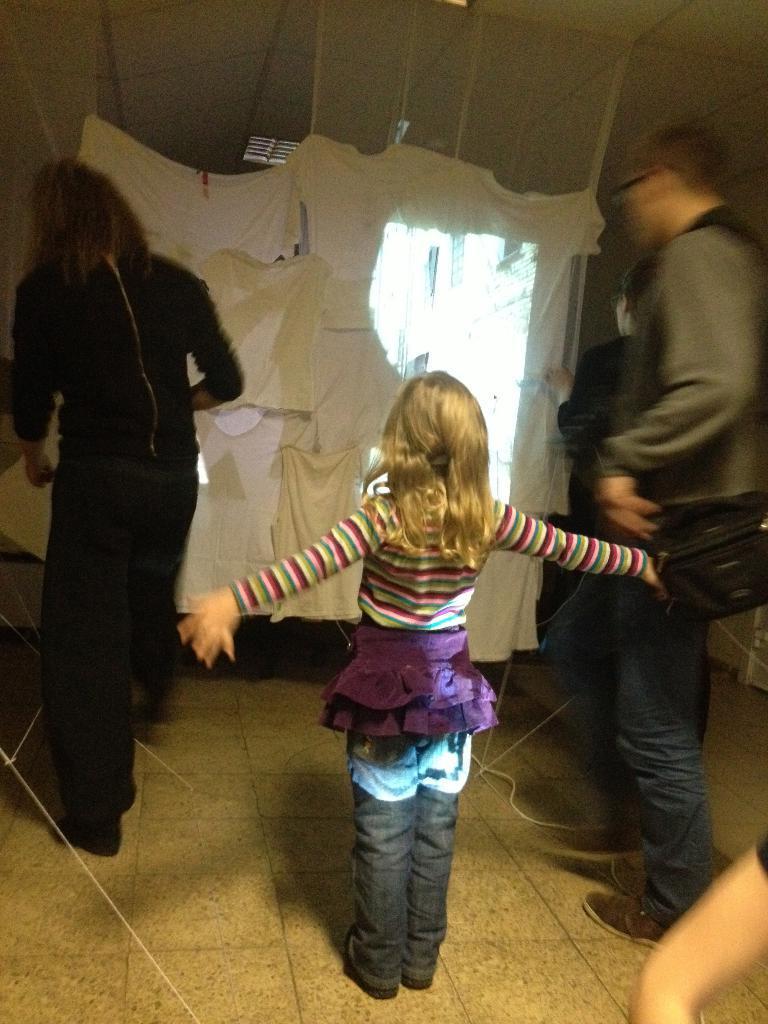How would you summarize this image in a sentence or two? In the picture there are two people adjusting a cloth and in front of that cloth a girl is standing by stretching her arms wide. 